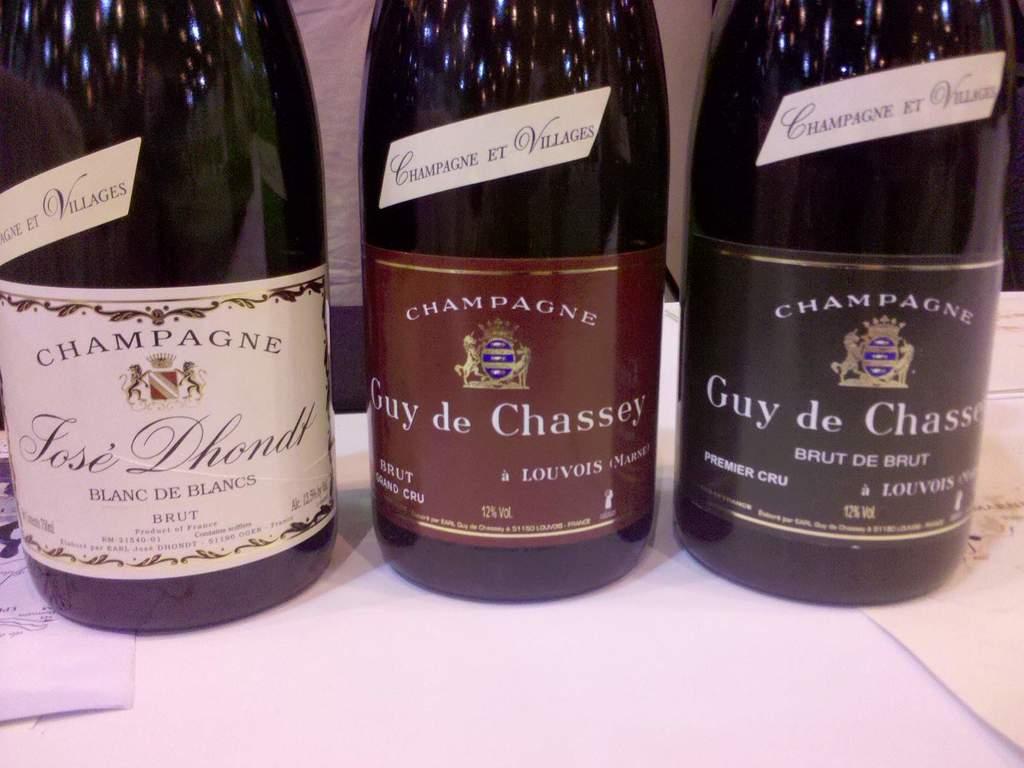What type of beverage is in the bottles?
Keep it short and to the point. Champagne. What is the left brand of alcohol?
Your response must be concise. Champagne. 